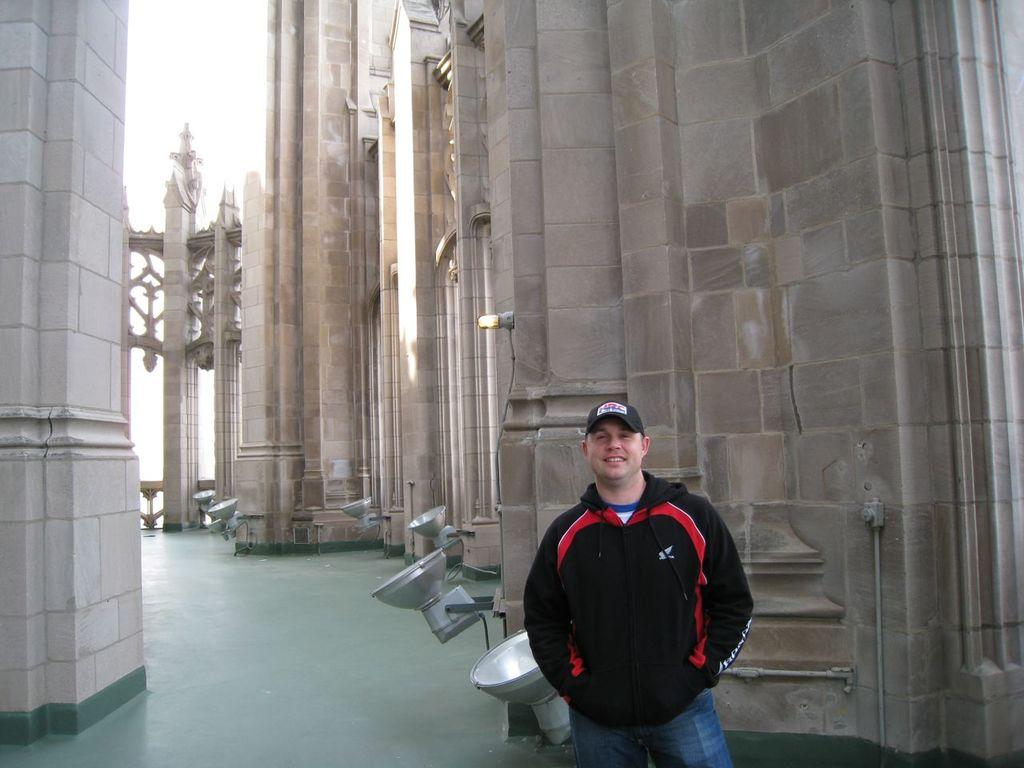What is the main subject of the image? There is a person in the image. What is the person doing in the image? The person is standing. What type of clothing is the person wearing? The person is wearing a cap and a coat. What can be seen in the background of the image? There are lights and a building in the background of the image. What is visible at the bottom of the image? There is a floor visible at the bottom of the image. How many patches can be seen on the deer in the image? There is no deer present in the image, and therefore no patches can be seen. 